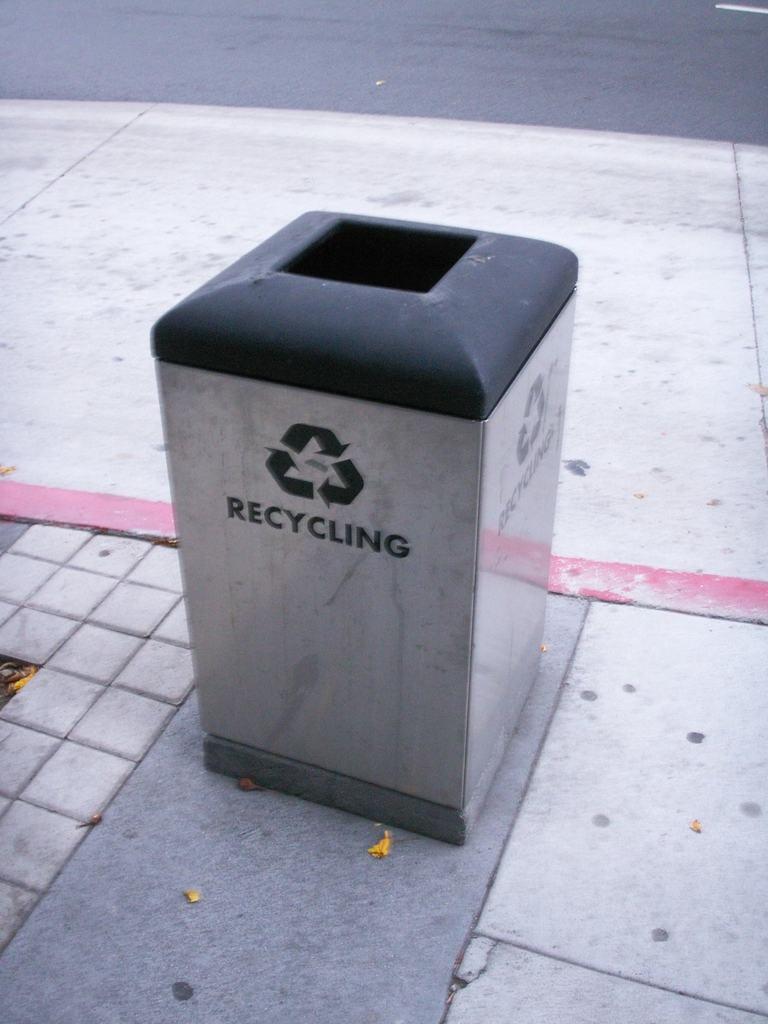What is this bin for?
Offer a terse response. Recycling. 